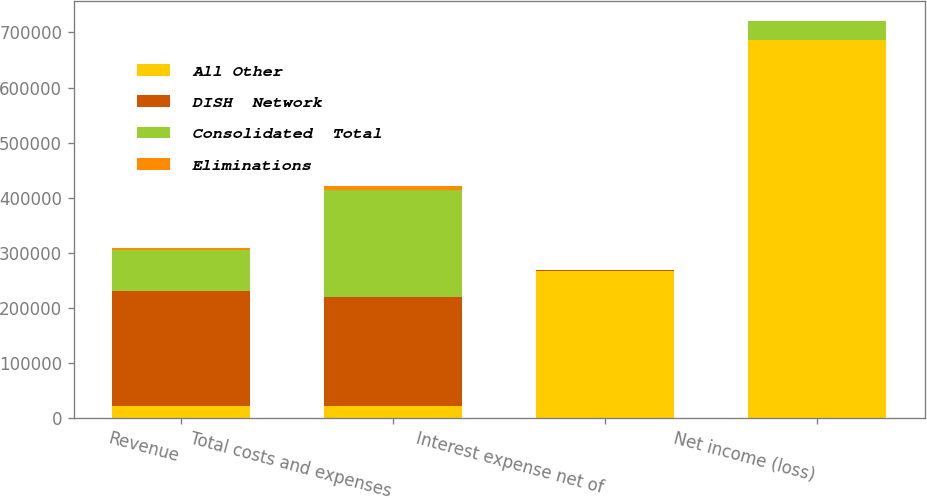Convert chart to OTSL. <chart><loc_0><loc_0><loc_500><loc_500><stacked_bar_chart><ecel><fcel>Revenue<fcel>Total costs and expenses<fcel>Interest expense net of<fcel>Net income (loss)<nl><fcel>All Other<fcel>21876<fcel>21876<fcel>267650<fcel>685599<nl><fcel>DISH  Network<fcel>207945<fcel>197073<fcel>233<fcel>155<nl><fcel>Consolidated  Total<fcel>75589<fcel>194363<fcel>438<fcel>35637<nl><fcel>Eliminations<fcel>3441<fcel>8115<fcel>331<fcel>209<nl></chart> 